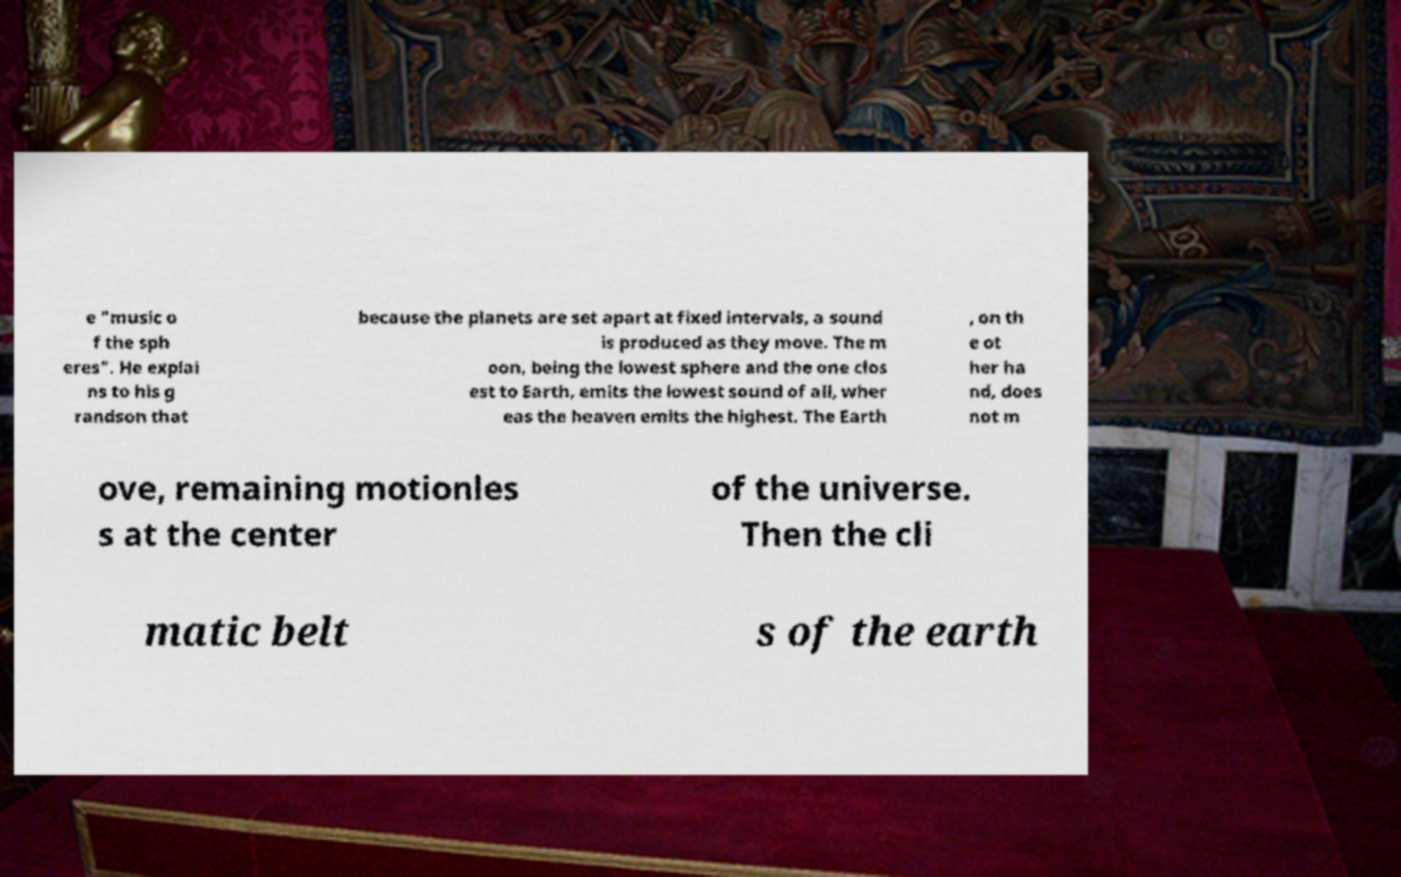Could you extract and type out the text from this image? e "music o f the sph eres". He explai ns to his g randson that because the planets are set apart at fixed intervals, a sound is produced as they move. The m oon, being the lowest sphere and the one clos est to Earth, emits the lowest sound of all, wher eas the heaven emits the highest. The Earth , on th e ot her ha nd, does not m ove, remaining motionles s at the center of the universe. Then the cli matic belt s of the earth 